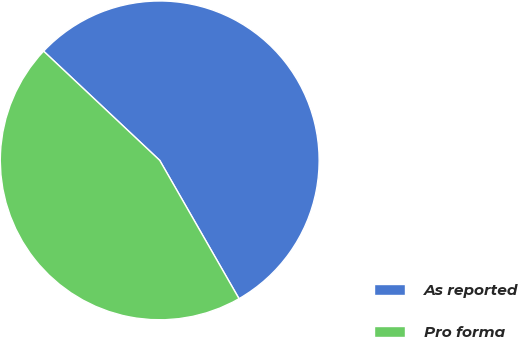Convert chart to OTSL. <chart><loc_0><loc_0><loc_500><loc_500><pie_chart><fcel>As reported<fcel>Pro forma<nl><fcel>54.7%<fcel>45.3%<nl></chart> 